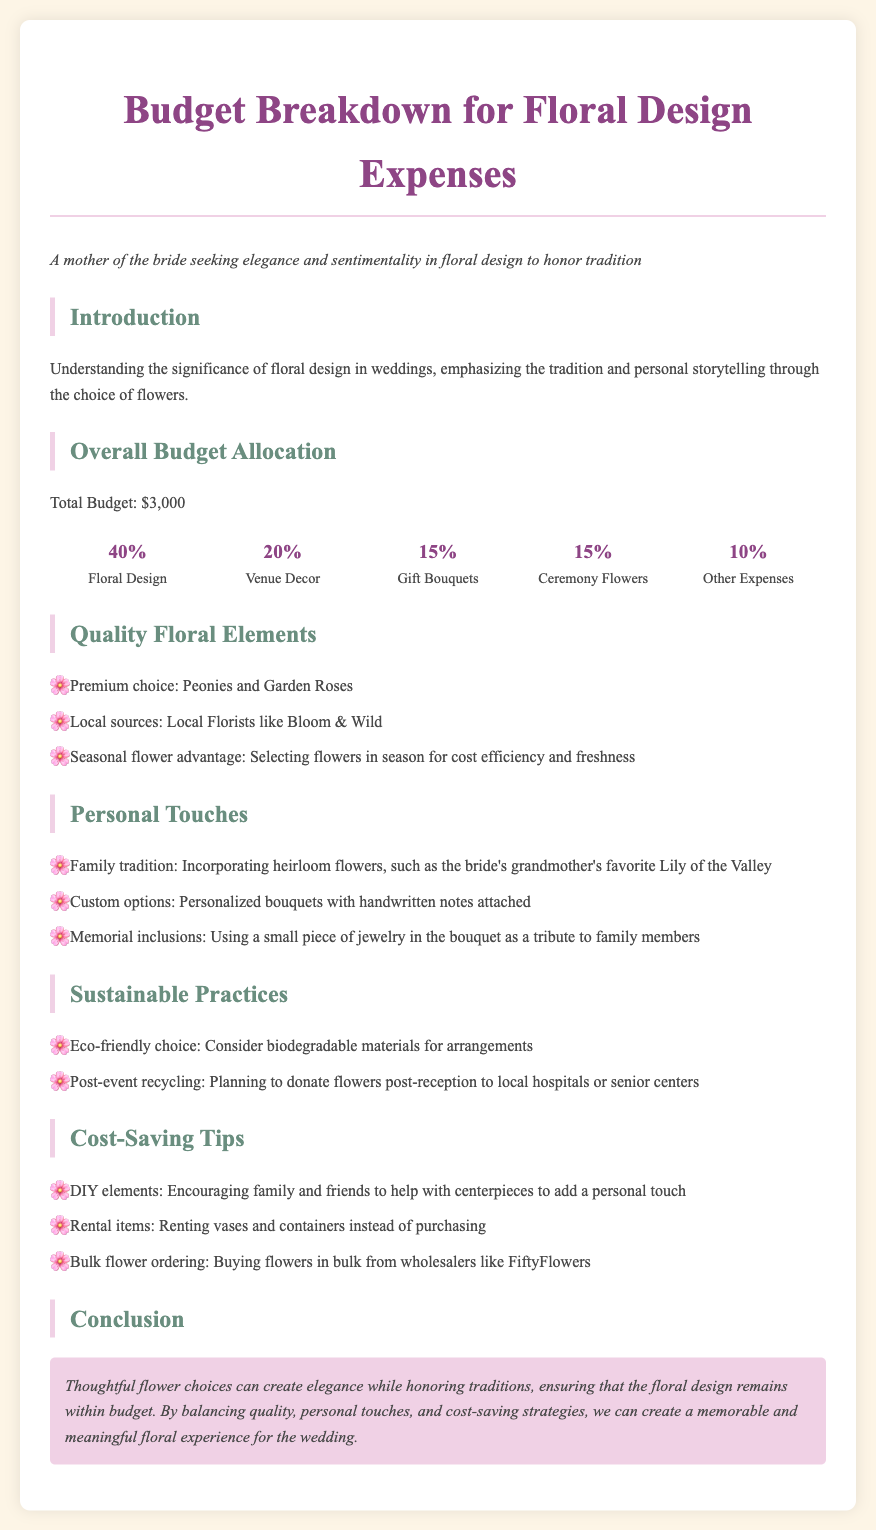What is the total budget for floral design? The total budget for floral design is explicitly stated as $3,000 in the document.
Answer: $3,000 What percentage of the budget is allocated to floral design? The budget allocation shows that 40% is designated for floral design.
Answer: 40% Which flowers are mentioned as premium choices? The document lists Peonies and Garden Roses as premium flower choices.
Answer: Peonies and Garden Roses What type of personalized option is suggested for bouquets? The document suggests including handwritten notes attached to personalized bouquets.
Answer: Handwritten notes What sustainable practice involves post-event actions? The document mentions planning to donate flowers post-reception as an eco-friendly practice.
Answer: Donate flowers What is a suggested cost-saving tip for arranging floral centerpieces? The document encourages family and friends to assist with centerpieces as a cost-saving tip.
Answer: Family and friends' help Which traditional flower is included in the personal touches? The document refers to the bride's grandmother's favorite flower, Lily of the Valley, as an heirloom.
Answer: Lily of the Valley What is one suggested rental item to save costs? The document suggests renting vases and containers instead of purchasing them for cost-saving.
Answer: Vases and containers How much of the budget is set aside for gift bouquets? The document states that 15% of the budget is allocated for gift bouquets.
Answer: 15% What is highlighted as an advantage in the quality floral elements? The document emphasizes using seasonal flowers for cost efficiency and freshness as an advantage.
Answer: Seasonal flower advantage 